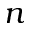Convert formula to latex. <formula><loc_0><loc_0><loc_500><loc_500>n</formula> 